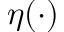<formula> <loc_0><loc_0><loc_500><loc_500>\eta ( \cdot )</formula> 